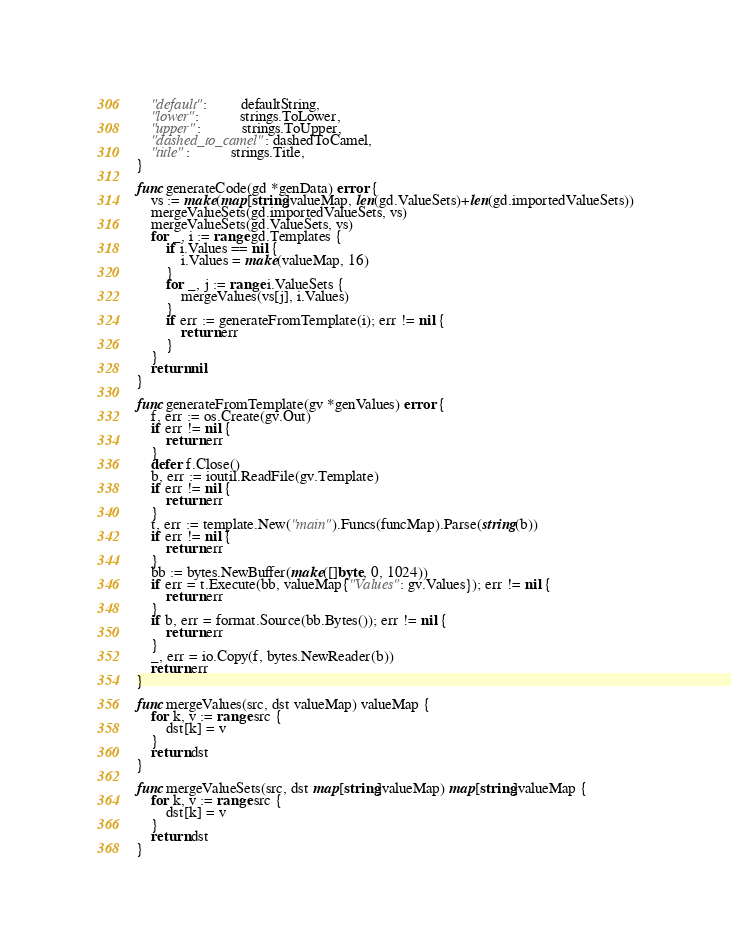Convert code to text. <code><loc_0><loc_0><loc_500><loc_500><_Go_>	"default":         defaultString,
	"lower":           strings.ToLower,
	"upper":           strings.ToUpper,
	"dashed_to_camel": dashedToCamel,
	"title":           strings.Title,
}

func generateCode(gd *genData) error {
	vs := make(map[string]valueMap, len(gd.ValueSets)+len(gd.importedValueSets))
	mergeValueSets(gd.importedValueSets, vs)
	mergeValueSets(gd.ValueSets, vs)
	for _, i := range gd.Templates {
		if i.Values == nil {
			i.Values = make(valueMap, 16)
		}
		for _, j := range i.ValueSets {
			mergeValues(vs[j], i.Values)
		}
		if err := generateFromTemplate(i); err != nil {
			return err
		}
	}
	return nil
}

func generateFromTemplate(gv *genValues) error {
	f, err := os.Create(gv.Out)
	if err != nil {
		return err
	}
	defer f.Close()
	b, err := ioutil.ReadFile(gv.Template)
	if err != nil {
		return err
	}
	t, err := template.New("main").Funcs(funcMap).Parse(string(b))
	if err != nil {
		return err
	}
	bb := bytes.NewBuffer(make([]byte, 0, 1024))
	if err = t.Execute(bb, valueMap{"Values": gv.Values}); err != nil {
		return err
	}
	if b, err = format.Source(bb.Bytes()); err != nil {
		return err
	}
	_, err = io.Copy(f, bytes.NewReader(b))
	return err
}

func mergeValues(src, dst valueMap) valueMap {
	for k, v := range src {
		dst[k] = v
	}
	return dst
}

func mergeValueSets(src, dst map[string]valueMap) map[string]valueMap {
	for k, v := range src {
		dst[k] = v
	}
	return dst
}
</code> 